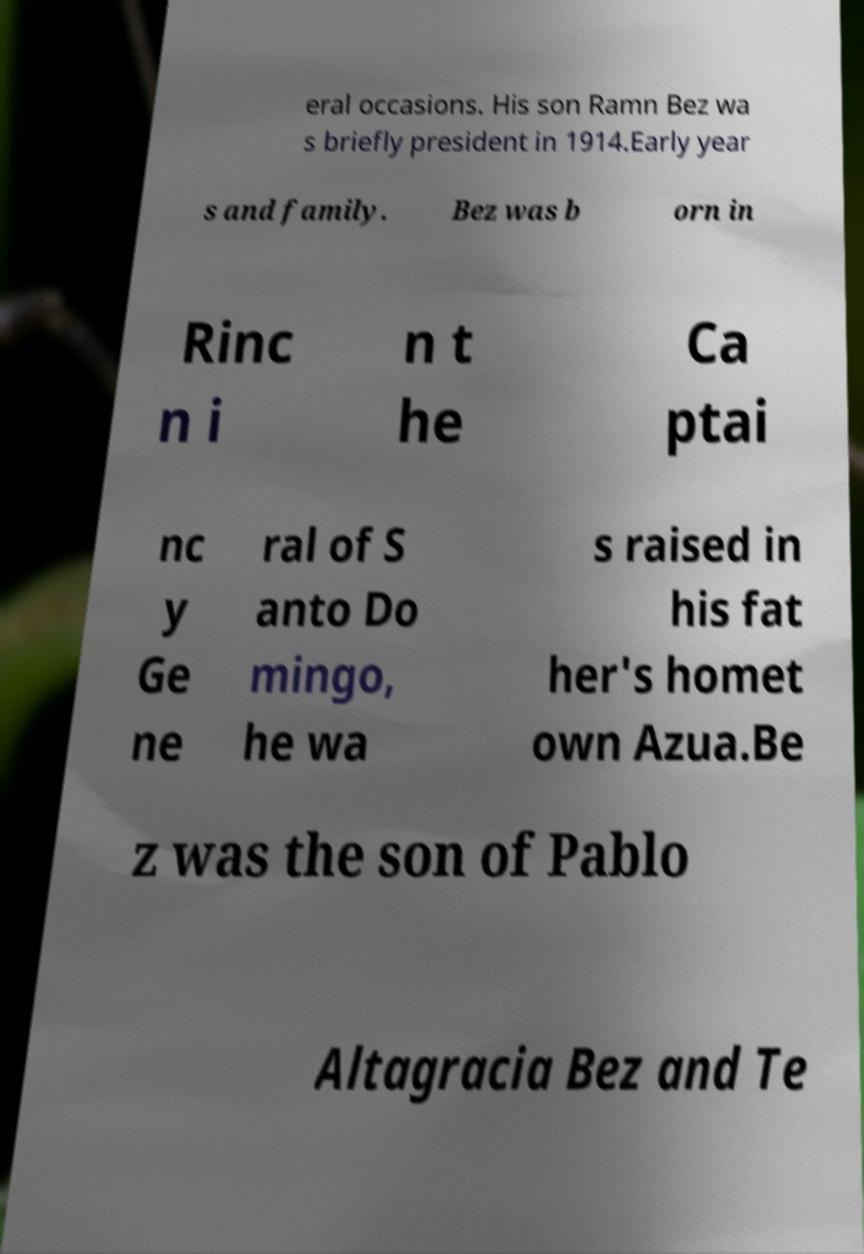What messages or text are displayed in this image? I need them in a readable, typed format. eral occasions. His son Ramn Bez wa s briefly president in 1914.Early year s and family. Bez was b orn in Rinc n i n t he Ca ptai nc y Ge ne ral of S anto Do mingo, he wa s raised in his fat her's homet own Azua.Be z was the son of Pablo Altagracia Bez and Te 